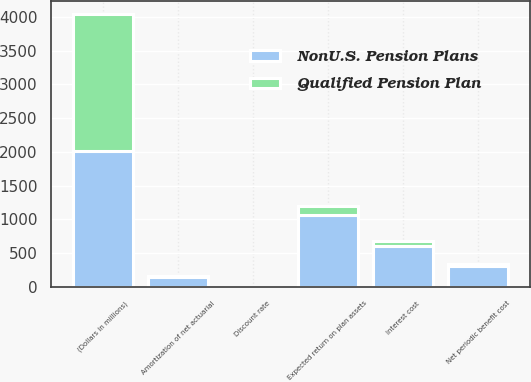<chart> <loc_0><loc_0><loc_500><loc_500><stacked_bar_chart><ecel><fcel>(Dollars in millions)<fcel>Interest cost<fcel>Expected return on plan assets<fcel>Amortization of net actuarial<fcel>Net periodic benefit cost<fcel>Discount rate<nl><fcel>NonU.S. Pension Plans<fcel>2017<fcel>606<fcel>1068<fcel>154<fcel>308<fcel>4.16<nl><fcel>Qualified Pension Plan<fcel>2017<fcel>72<fcel>136<fcel>8<fcel>39<fcel>2.56<nl></chart> 